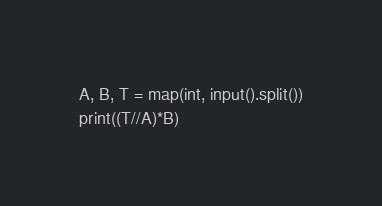Convert code to text. <code><loc_0><loc_0><loc_500><loc_500><_Python_>A, B, T = map(int, input().split())
print((T//A)*B)
</code> 